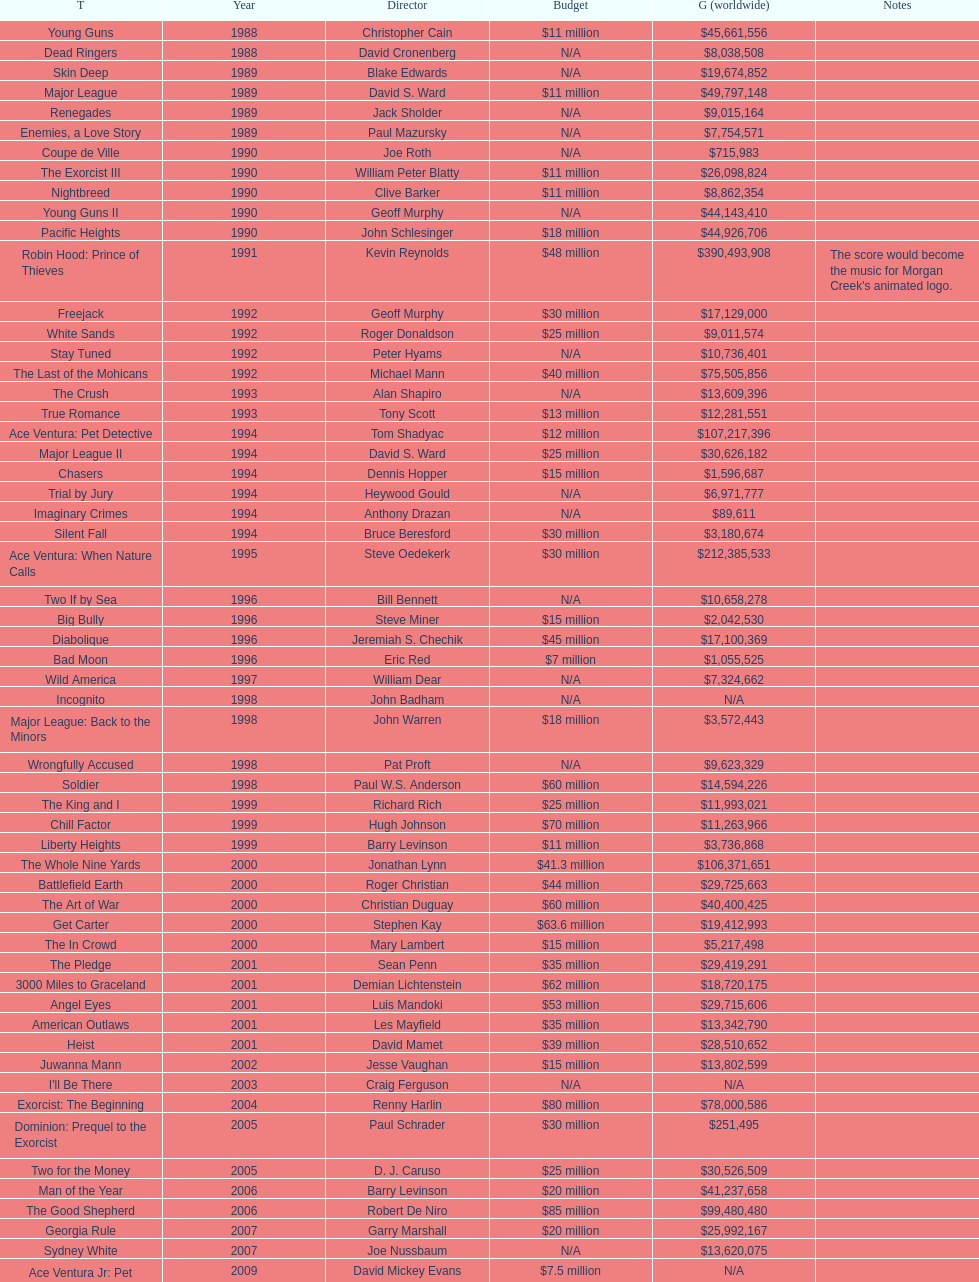How many movies were produced in the year 1990? 5. 